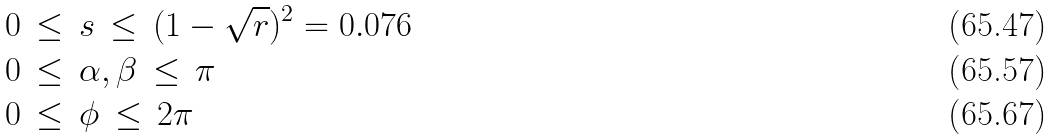Convert formula to latex. <formula><loc_0><loc_0><loc_500><loc_500>0 \, & \leq \, s \, \leq \, ( 1 - \sqrt { r } ) ^ { 2 } = 0 . 0 7 6 \\ 0 \, & \leq \, \alpha , \beta \, \leq \, \pi \\ 0 \, & \leq \, \phi \, \leq \, 2 \pi</formula> 